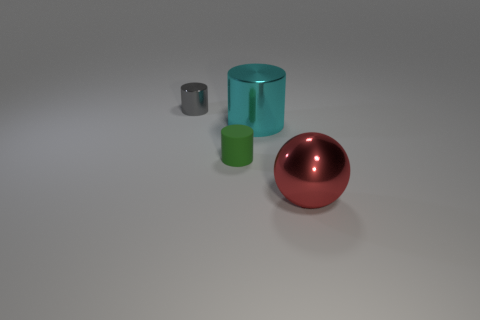Add 2 metal things. How many objects exist? 6 Subtract all cylinders. How many objects are left? 1 Add 1 big things. How many big things exist? 3 Subtract 1 gray cylinders. How many objects are left? 3 Subtract all large blue balls. Subtract all large cylinders. How many objects are left? 3 Add 3 large red metallic spheres. How many large red metallic spheres are left? 4 